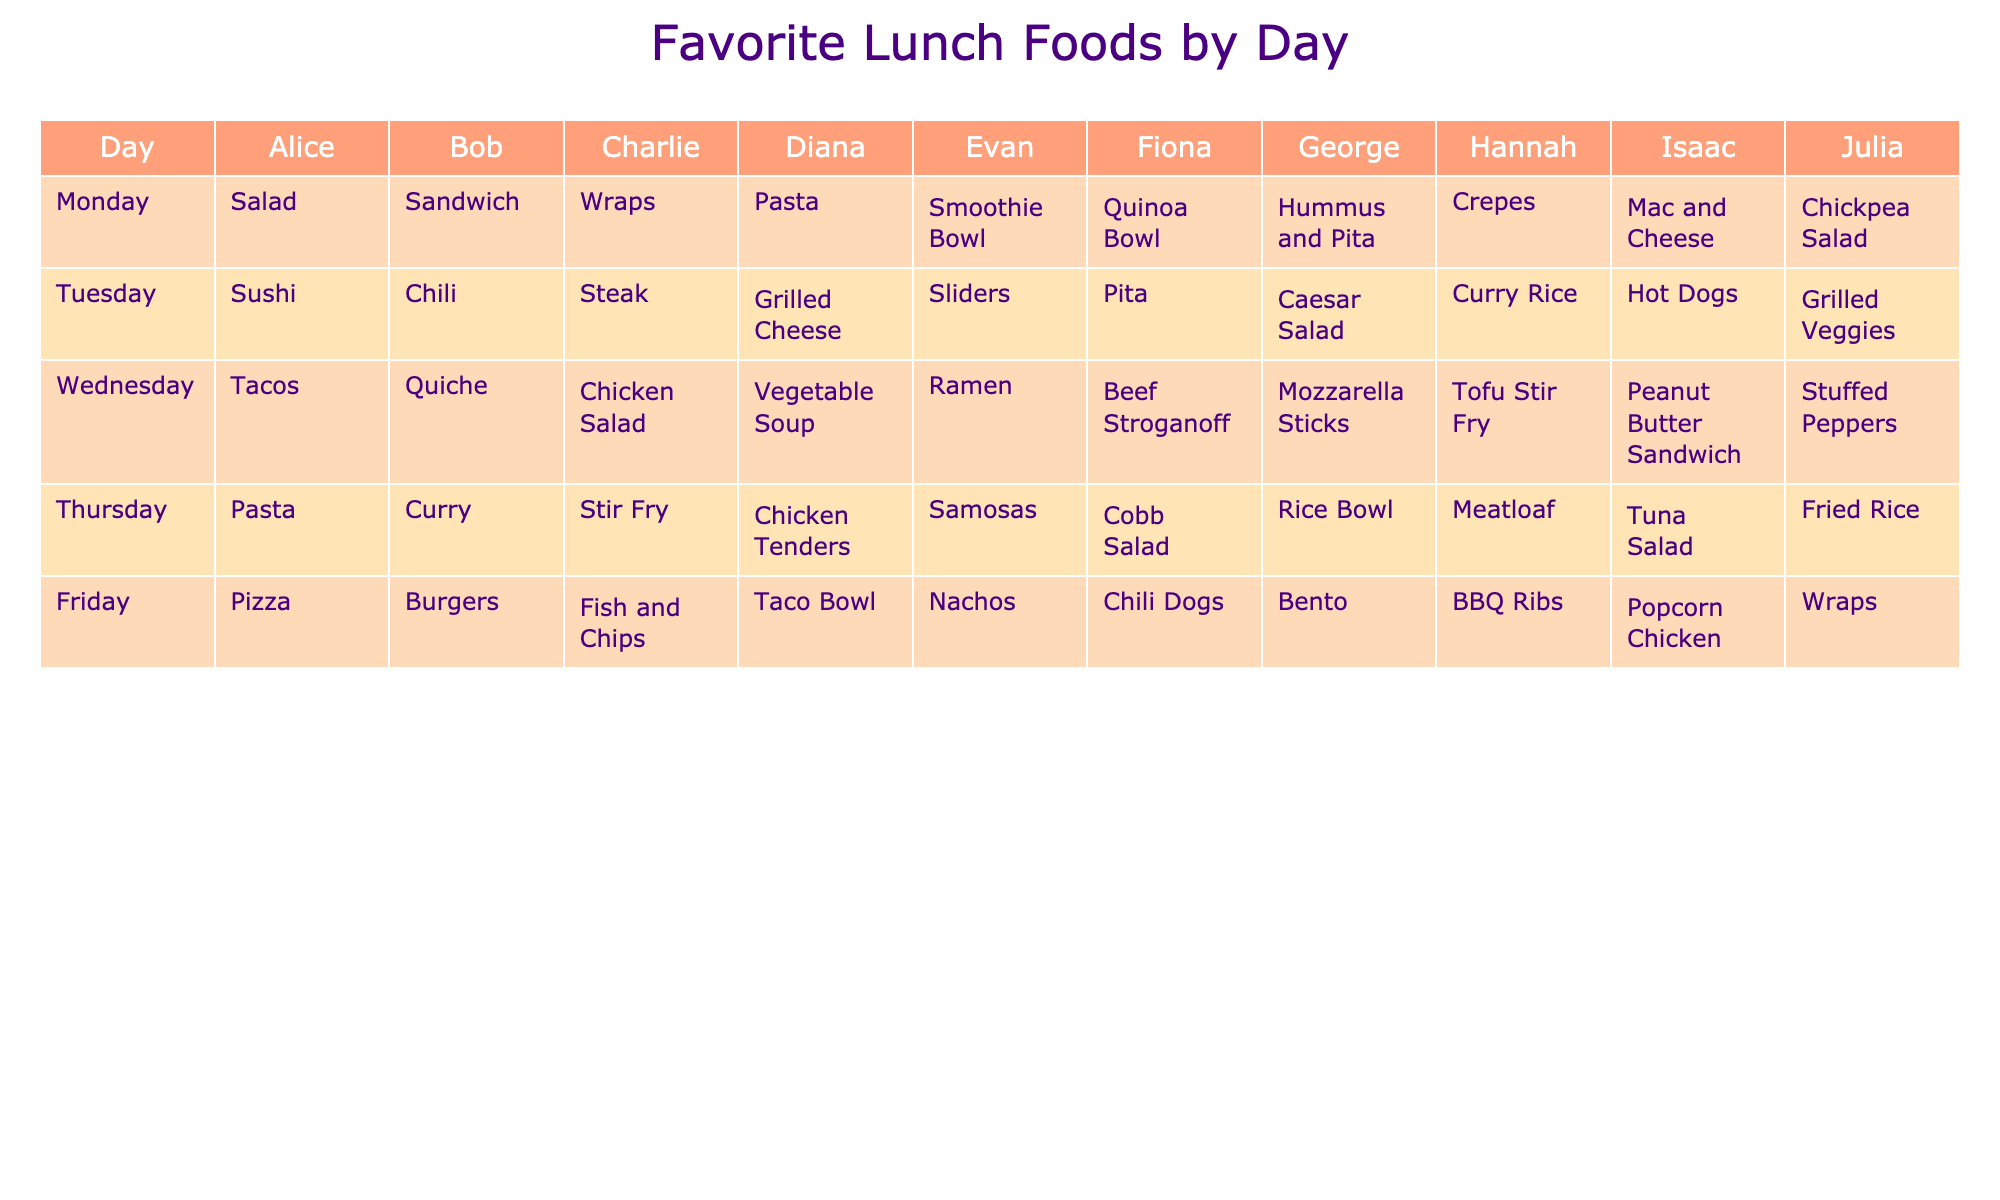What is Hannah's favorite lunch food on Friday? Looking at the row for Hannah, the entry under Friday is BBQ Ribs.
Answer: BBQ Ribs Which student prefers Pasta on Monday? Referring to the table, only Diana has Pasta listed under Monday.
Answer: Diana How many students prefer Tacos on Wednesday? By checking each student's food choice on Wednesday, only Alice and Diana have Tacos listed. Therefore, the count is 2.
Answer: 2 Did any student list Quinoa Bowl for lunch on Friday? Looking at the Friday column, the only entry is Fiona, who prefers Chili Dogs instead of Quinoa Bowl. Thus, the answer is no.
Answer: No On which day does George prefer Mozzarella Sticks? Checking George's row, it can be seen that he prefers Mozzarella Sticks on Wednesday.
Answer: Wednesday What is the total number of unique foods listed for Monday? Counting the unique foods from the Monday column—Salad, Sandwich, Wraps, Pasta, Smoothie Bowl, Quinoa Bowl, Hummus and Pita, and Mac and Cheese—we find 8 unique foods.
Answer: 8 Which student has the same favorite food on Tuesday and Thursday? By examining the Tuesday and Thursday columns for each student, no student shares the same favorite food for both days. Thus, the answer is no.
Answer: No What is the most popular food item among students on Friday? Checking the Friday column, the food items listed are: Pizza, Burgers, Fish and Chips, Taco Bowl, Nachos, Chili Dogs, Bento, BBQ Ribs, Popcorn Chicken, and Wraps. We can see that no food items repeat, so there is no single most popular item.
Answer: No single most popular item How many students have a different favorite food on Thursday compared to Tuesday? By comparing the students' entries for Thursday and Tuesday, we find that only Fiona and Julia have the same food on both days, which leaves the remaining 8 students with different foods.
Answer: 8 